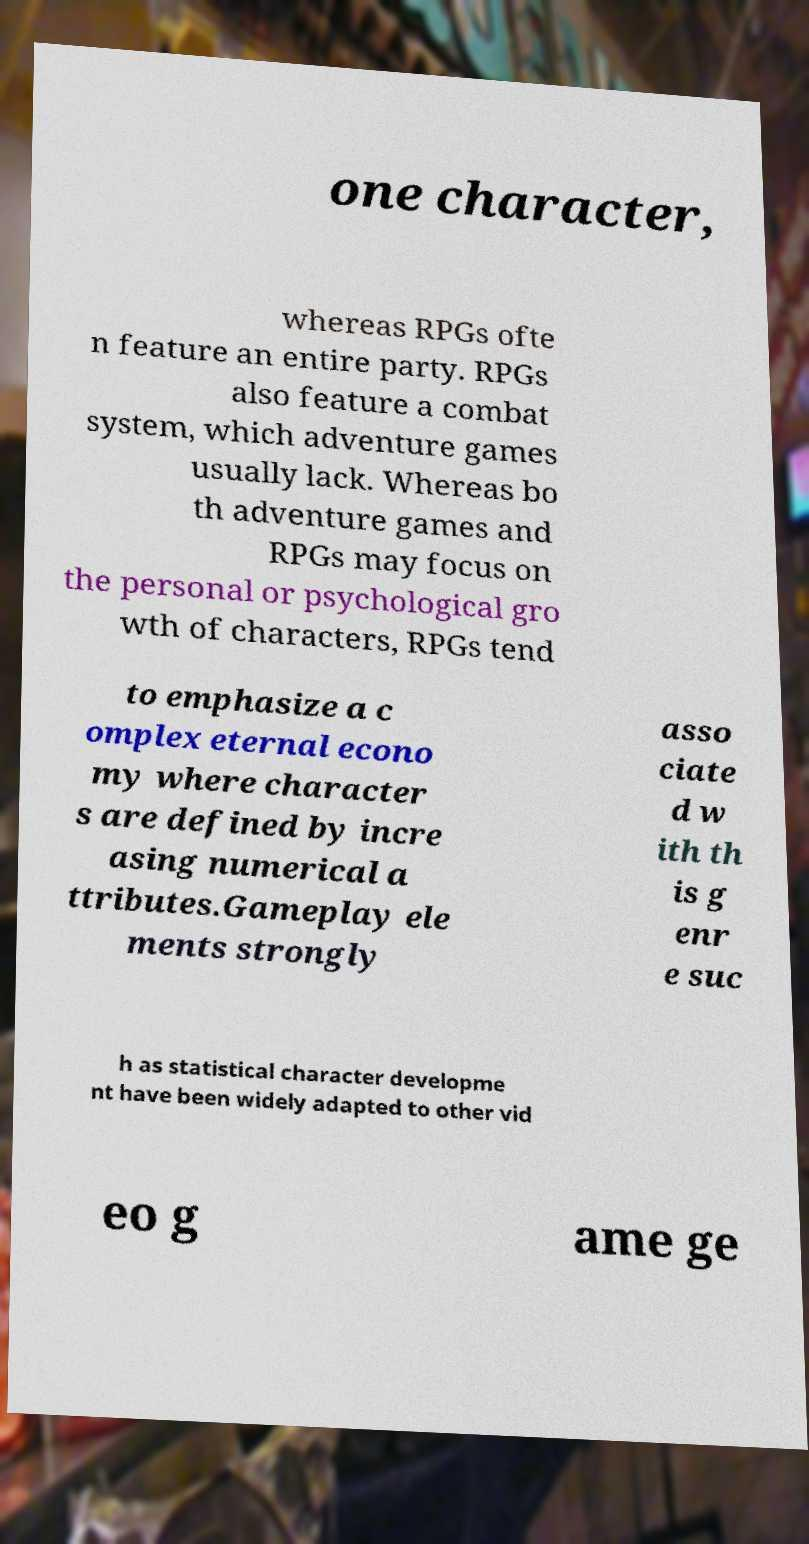Please read and relay the text visible in this image. What does it say? one character, whereas RPGs ofte n feature an entire party. RPGs also feature a combat system, which adventure games usually lack. Whereas bo th adventure games and RPGs may focus on the personal or psychological gro wth of characters, RPGs tend to emphasize a c omplex eternal econo my where character s are defined by incre asing numerical a ttributes.Gameplay ele ments strongly asso ciate d w ith th is g enr e suc h as statistical character developme nt have been widely adapted to other vid eo g ame ge 